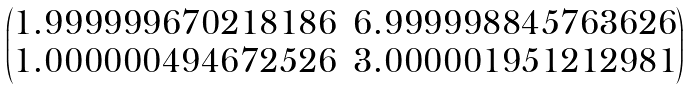Convert formula to latex. <formula><loc_0><loc_0><loc_500><loc_500>\begin{pmatrix} 1 . 9 9 9 9 9 9 6 7 0 2 1 8 1 8 6 & 6 . 9 9 9 9 9 8 8 4 5 7 6 3 6 2 6 \\ 1 . 0 0 0 0 0 0 4 9 4 6 7 2 5 2 6 & 3 . 0 0 0 0 0 1 9 5 1 2 1 2 9 8 1 \end{pmatrix}</formula> 